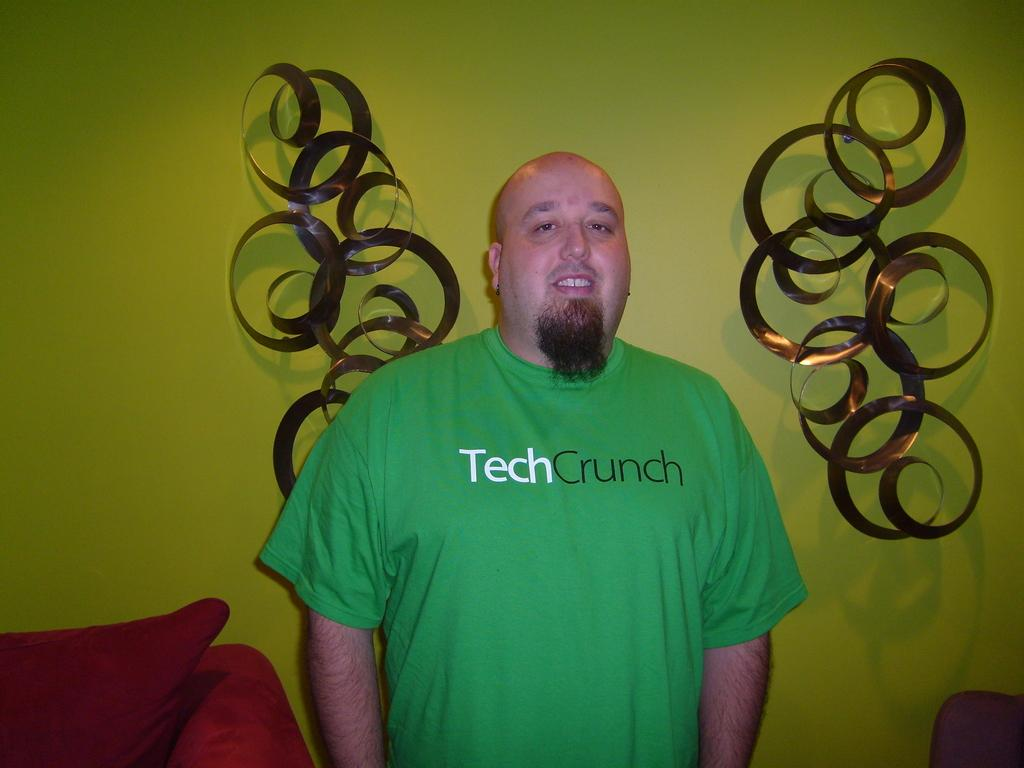What is the main subject of the image? There is a person in the image. What is the person wearing? The person is wearing a green t-shirt. What is the person's posture in the image? The person is standing. What piece of furniture is located beside the person? There is a couch beside the person. What can be seen on the wall in the background? There is a wall with decoration in the background. What type of dress is the person wearing in the image? The person is not wearing a dress; they are wearing a green t-shirt. How many stitches can be seen on the person's clothing in the image? There is no mention of stitches on the person's clothing in the image. 